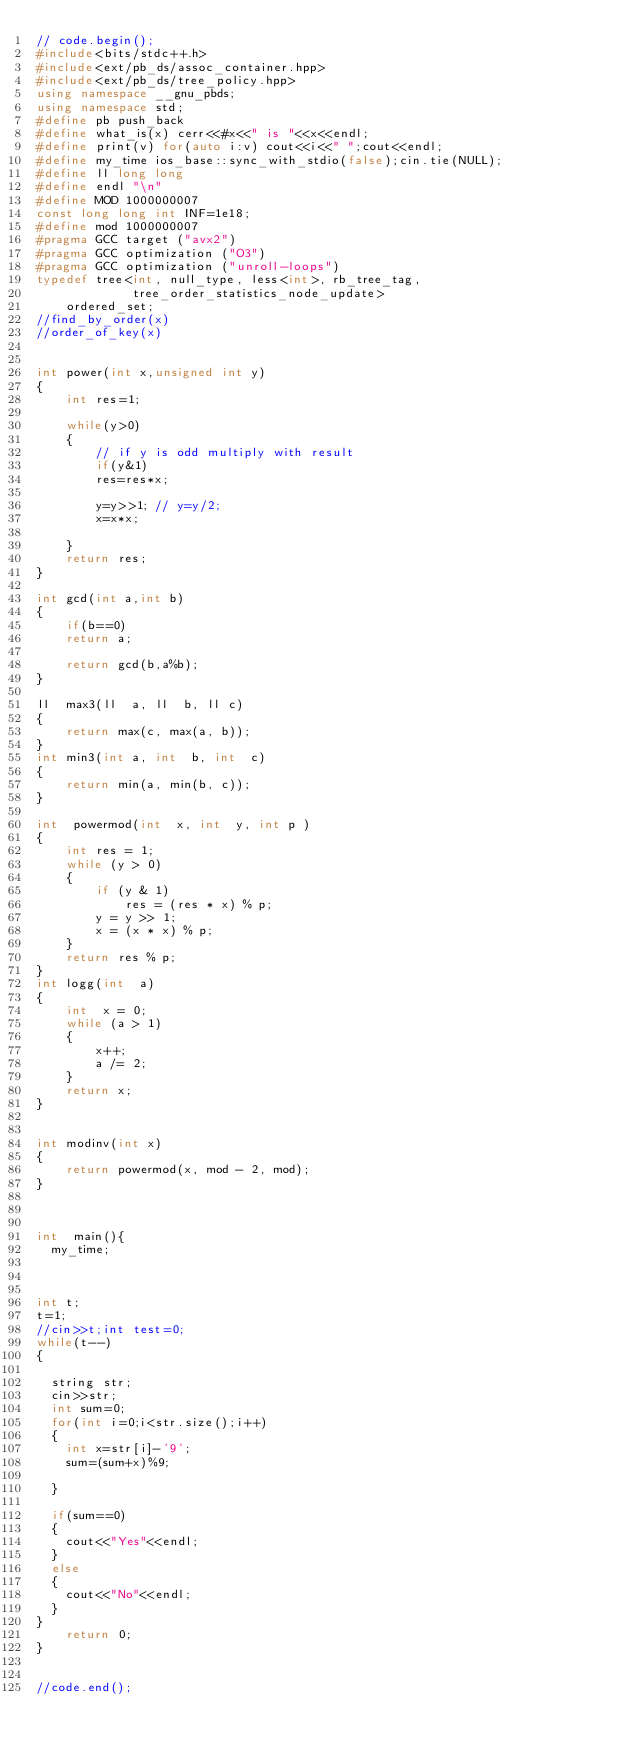<code> <loc_0><loc_0><loc_500><loc_500><_C++_>// code.begin();
#include<bits/stdc++.h>
#include<ext/pb_ds/assoc_container.hpp>
#include<ext/pb_ds/tree_policy.hpp>
using namespace __gnu_pbds;
using namespace std;
#define pb push_back 
#define what_is(x) cerr<<#x<<" is "<<x<<endl;
#define print(v) for(auto i:v) cout<<i<<" ";cout<<endl;
#define my_time ios_base::sync_with_stdio(false);cin.tie(NULL);
#define ll long long 
#define endl "\n"
#define MOD 1000000007
const long long int INF=1e18;
#define mod 1000000007
#pragma GCC target ("avx2")
#pragma GCC optimization ("O3")
#pragma GCC optimization ("unroll-loops")
typedef tree<int, null_type, less<int>, rb_tree_tag, 
             tree_order_statistics_node_update> 
    ordered_set; 
//find_by_order(x)
//order_of_key(x)  


int power(int x,unsigned int y)
{
    int res=1;
    
    while(y>0)
    {
        // if y is odd multiply with result
        if(y&1)
        res=res*x;
        
        y=y>>1; // y=y/2;
        x=x*x;
        
    }
    return res;
}

int gcd(int a,int b)
{
    if(b==0)
    return a;
    
    return gcd(b,a%b);
}

ll  max3(ll  a, ll  b, ll c)
{
    return max(c, max(a, b));
}
int min3(int a, int  b, int  c)
{
    return min(a, min(b, c));
}

int  powermod(int  x, int  y, int p )
{
    int res = 1;
    while (y > 0)
    {
        if (y & 1)
            res = (res * x) % p;
        y = y >> 1;
        x = (x * x) % p;
    }
    return res % p;
}
int logg(int  a)
{
    int  x = 0;
    while (a > 1)
    {
        x++;
        a /= 2;
    }
    return x;
}


int modinv(int x)
{
    return powermod(x, mod - 2, mod);
}



int  main(){
	my_time;



int t;
t=1;
//cin>>t;int test=0;
while(t--)
{
	
	string str;
	cin>>str;
	int sum=0;
	for(int i=0;i<str.size();i++)
	{
		int x=str[i]-'9';
		sum=(sum+x)%9;
		
	}
	
	if(sum==0)
	{
		cout<<"Yes"<<endl;
	}
	else
	{
		cout<<"No"<<endl;
	}
}
    return 0;
}


//code.end();



</code> 